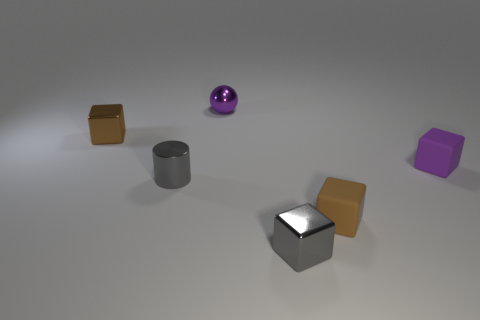How many gray blocks are the same size as the purple shiny thing?
Your answer should be very brief. 1. What is the size of the object that is the same color as the small cylinder?
Your response must be concise. Small. How many small objects are either gray shiny objects or red metallic balls?
Provide a succinct answer. 2. What number of tiny metal cubes are there?
Your answer should be compact. 2. Are there the same number of metal spheres left of the purple metallic thing and shiny objects in front of the tiny brown rubber thing?
Offer a terse response. No. There is a purple rubber object; are there any metallic things behind it?
Provide a short and direct response. Yes. What color is the shiny sphere left of the tiny gray metallic cube?
Keep it short and to the point. Purple. There is a small brown cube that is in front of the small block that is left of the purple metal thing; what is its material?
Make the answer very short. Rubber. Is the number of small purple objects that are in front of the tiny brown matte cube less than the number of tiny gray objects to the right of the tiny purple matte object?
Make the answer very short. No. What number of gray things are either metal spheres or tiny metallic things?
Your response must be concise. 2. 